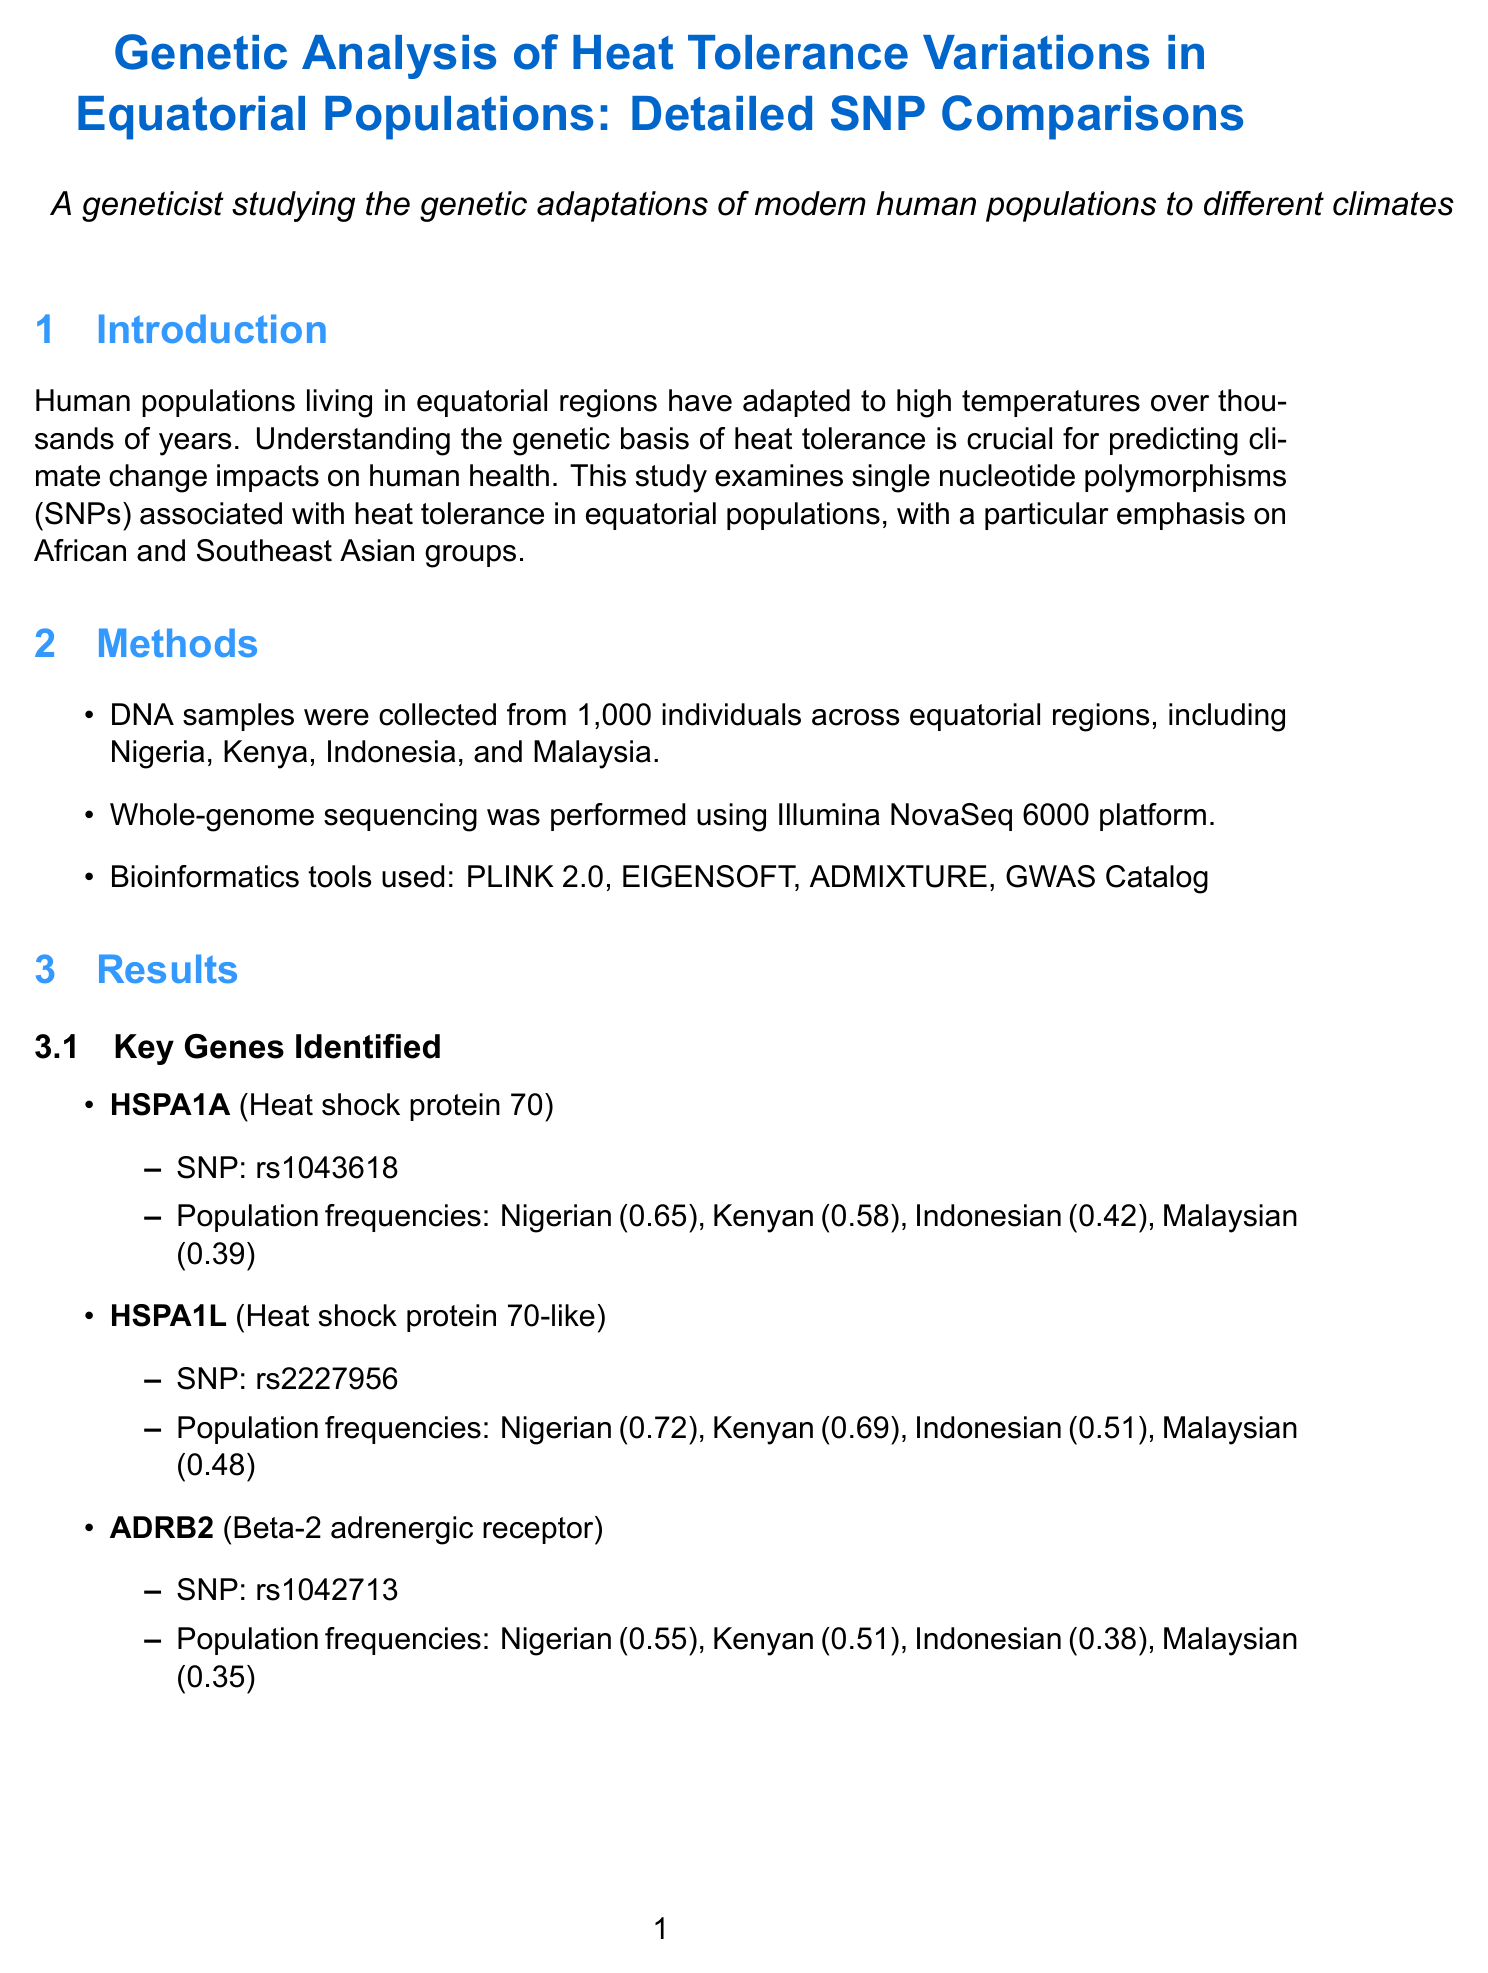What is the title of the report? The title of the report is the key topic presented at the beginning, summarizing the focus on genetic analysis and heat tolerance.
Answer: Genetic Analysis of Heat Tolerance Variations in Equatorial Populations: Detailed SNP Comparisons How many DNA samples were collected for this study? The study mentions the collection of DNA samples from a specific number of individuals, which is stated in the methods section.
Answer: 1,000 Which populations were involved in the study? The report lists the specific geographical regions from which DNA samples were collected, indicating the populations studied.
Answer: Nigeria, Kenya, Indonesia, Malaysia What SNP is associated with the gene HSPA1A? The SNP related to HSPA1A is explicitly provided in the results section, along with its gene name and function.
Answer: rs1043618 Which bioinformatics tools were used in the analysis? The methods section outlines the tools utilized for bioinformatics analysis, highlighting their importance in data processing.
Answer: PLINK 2.0, EIGENSOFT, ADMIXTURE, GWAS Catalog What evolutionary implication is discussed regarding African populations? The document points out a specific observation about SNP frequency and adaptation in African populations in the discussion section.
Answer: A longer history of adaptation to hot climates What are some physiological adaptations mentioned in the results? The report identifies specific physiological traits associated with heat tolerance in equatorial populations.
Answer: Increased sweat gland density, Enhanced vasodilation capacity, Optimized electrolyte balance What future direction is mentioned for this research? A future research direction is provided in the conclusion, suggesting areas for further investigation to validate findings.
Answer: Functional studies to validate the role of identified SNPs in heat tolerance 